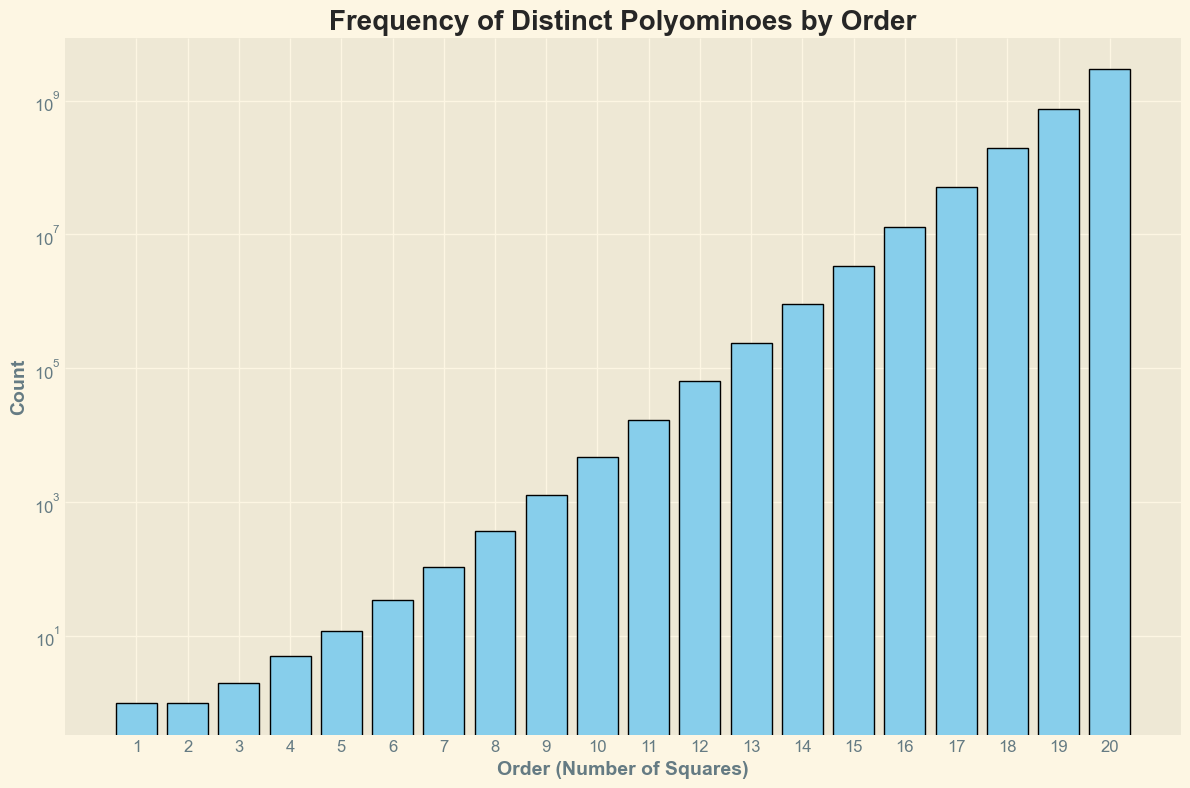How many distinct polyominoes are there for orders 10 and 15 combined? First, refer to the y-values of the bars corresponding to orders 10 and 15 in the figure. The count for order 10 is 4655, and for order 15, it is 3426576. Add these two values: 4655 + 3426576 = 3431231.
Answer: 3431231 Which order has the highest count of distinct polyominoes? Observe the bars' heights in the plot. The bar representing order 20 is the tallest, indicating the highest count.
Answer: Order 20 What’s the median count of distinct polyominoes for the orders listed? To find the median, list all counts and find the middle value. The counts are: [1, 1, 2, 5, 12, 35, 108, 369, 1285, 4655, 17073, 63600, 238591, 901971, 3426576, 13121033, 50586136, 195112221, 755966361, 2939566307]. The median is the average of the 10th and 11th values: (4655 + 17073) / 2 = 10864.
Answer: 10864 How does the count of distinct polyominoes change as the order increases? The plot shows a log-scaled y-axis where counts increase exponentially with the order. The bars grow rapidly in height, indicating a sharp increase in counts as the order rises.
Answer: Increases exponentially At which order does the count of distinct polyominoes first exceed 1000? Find the first bar where the y-value is greater than 1000. For order 9, the count is 1285, which is the first value above 1000.
Answer: Order 9 